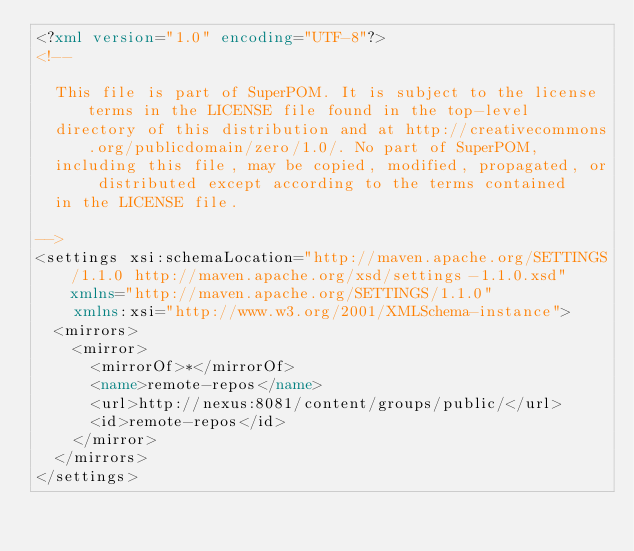Convert code to text. <code><loc_0><loc_0><loc_500><loc_500><_XML_><?xml version="1.0" encoding="UTF-8"?>
<!--

	This file is part of SuperPOM. It is subject to the license terms in the LICENSE file found in the top-level
	directory of this distribution and at http://creativecommons.org/publicdomain/zero/1.0/. No part of SuperPOM,
	including this file, may be copied, modified, propagated, or distributed except according to the terms contained
	in the LICENSE file.

-->
<settings xsi:schemaLocation="http://maven.apache.org/SETTINGS/1.1.0 http://maven.apache.org/xsd/settings-1.1.0.xsd" xmlns="http://maven.apache.org/SETTINGS/1.1.0"
    xmlns:xsi="http://www.w3.org/2001/XMLSchema-instance">
  <mirrors>
    <mirror>
      <mirrorOf>*</mirrorOf>
      <name>remote-repos</name>
      <url>http://nexus:8081/content/groups/public/</url>
      <id>remote-repos</id>
    </mirror>
  </mirrors>
</settings>
</code> 